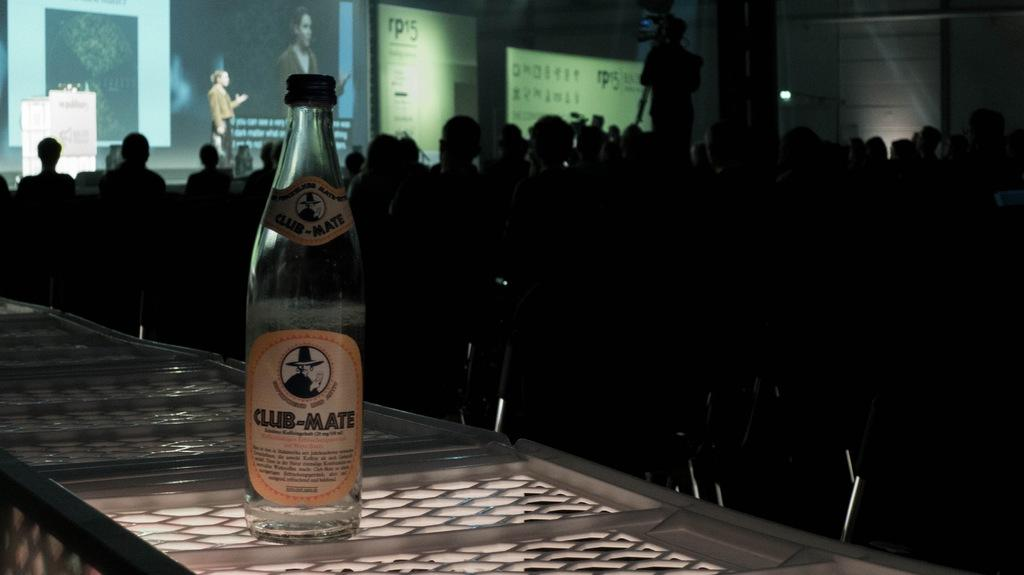<image>
Share a concise interpretation of the image provided. Bottle of Club-Mate alcohol bottle in front of a group of people watching a presentation. 